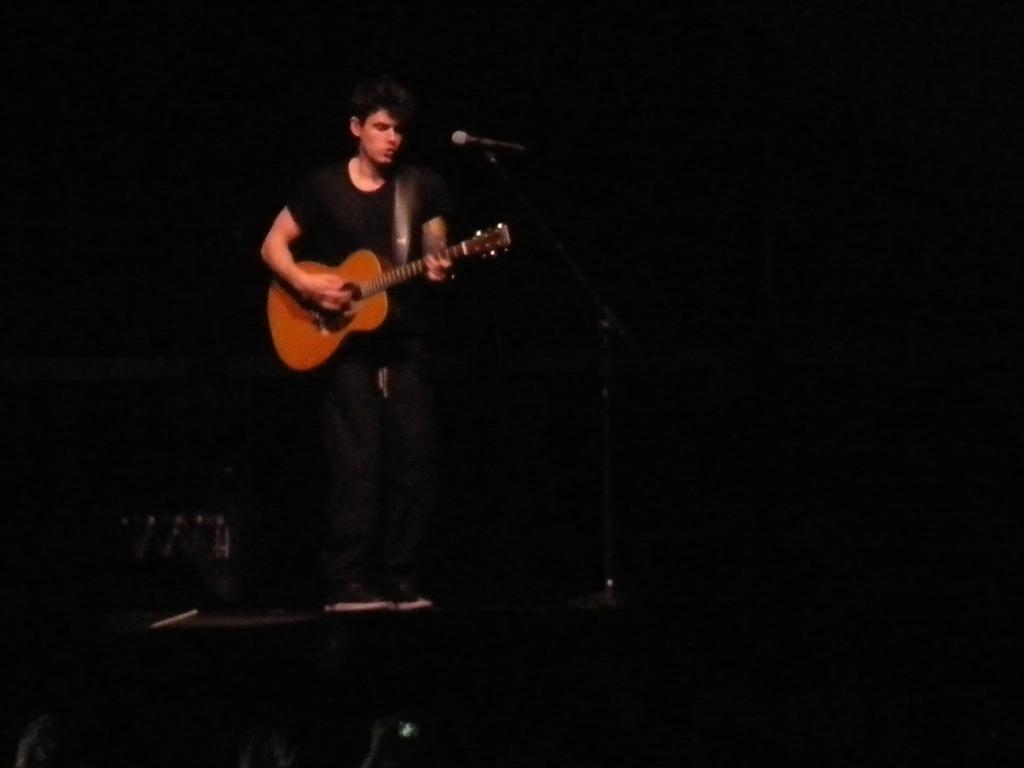Please provide a concise description of this image. In this picture a man is playing guitar. he is wearing black dress. There is mic in front of him. 